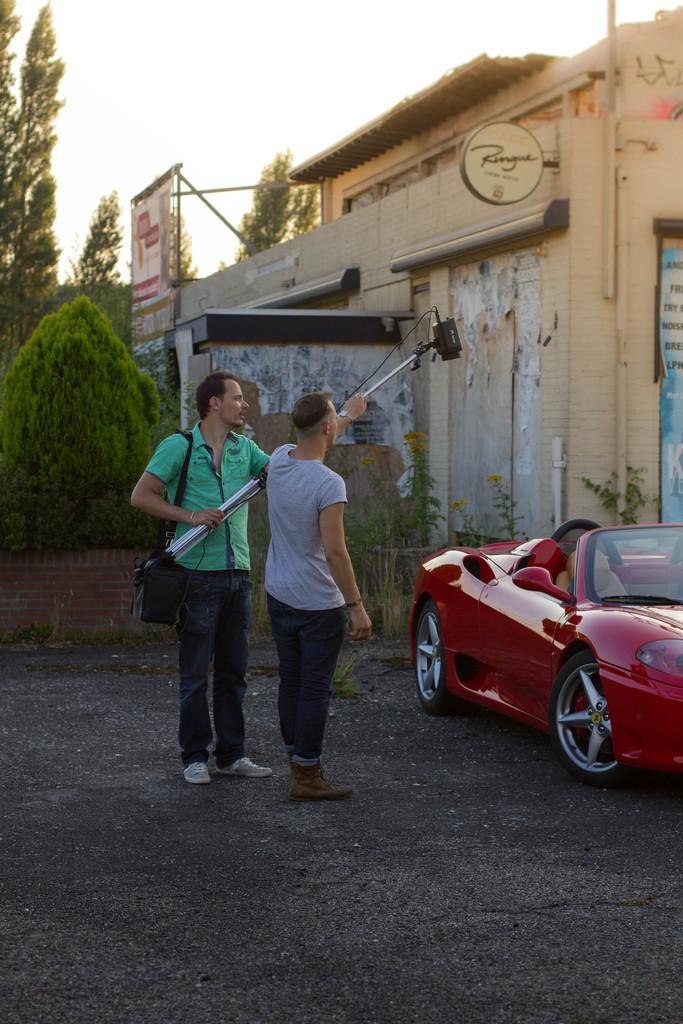Describe this image in one or two sentences. In this image, we can see two people are standing and holding a rod with camera. Here a person is carrying a bag. Background we can see house, walls, trees, plants, pipes, banners. Right side of the image, we can see a car. Top of the image, there is a sky. 